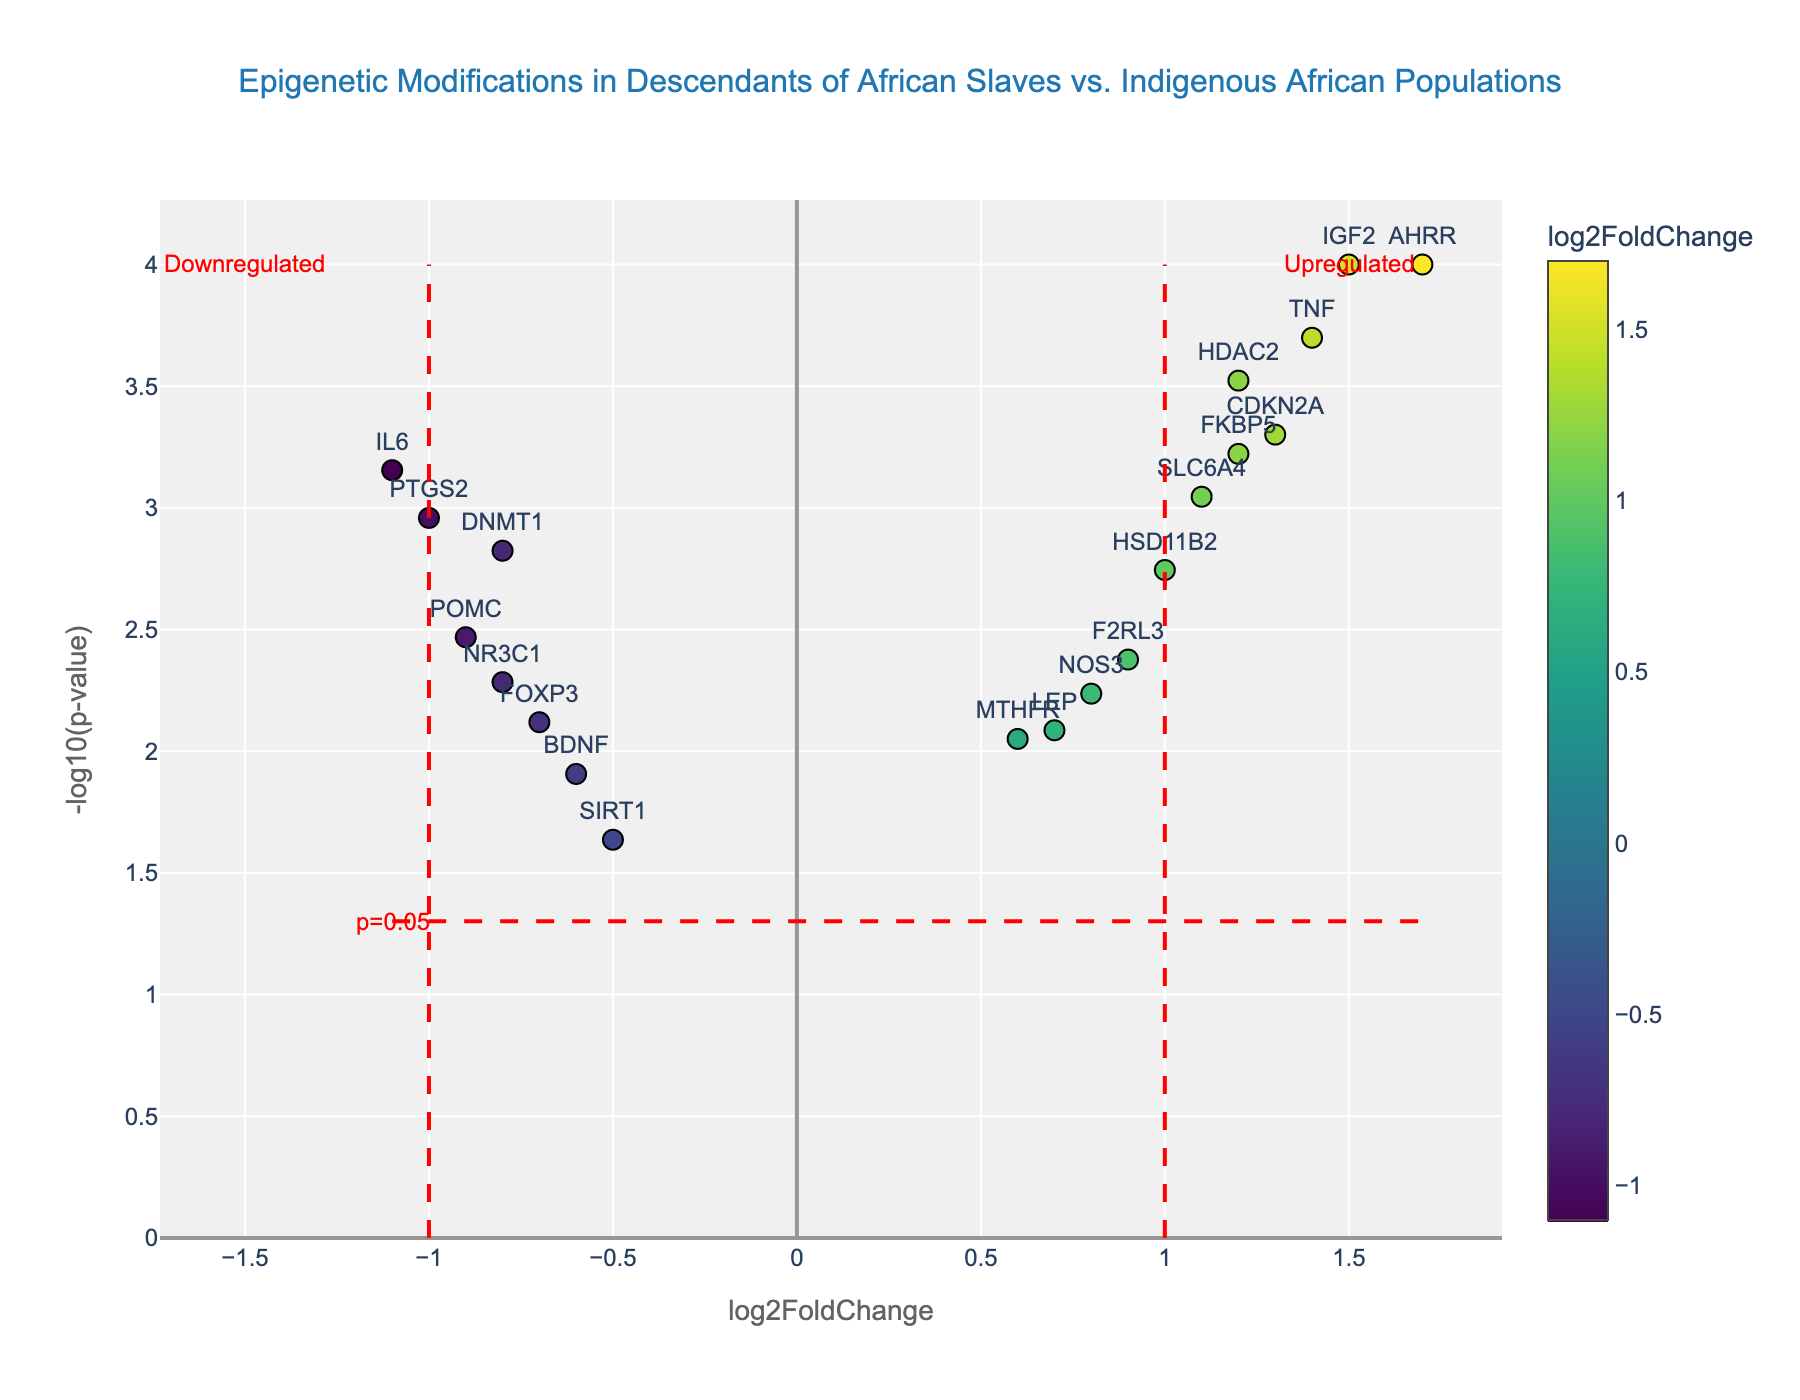What's the title of the figure? The title is usually positioned at the top center of the figure. Here, the title is displayed as 'Epigenetic Modifications in Descendants of African Slaves vs. Indigenous African Populations'.
Answer: Epigenetic Modifications in Descendants of African Slaves vs. Indigenous African Populations How many genes have a negative log2FoldChange? To determine the number of genes with negative log2FoldChange, count the data points to the left of the vertical zero line on the x-axis. Here, genes like DNMT1, SIRT1, IL6, FOXP3, PTGS2, BDNF, POMC, and NR3C1 fall to the left.
Answer: 8 Which gene has the highest -log10(p-value)? To find this, look for the gene positioned the highest on the y-axis. In this figure, AHRR has the highest value.
Answer: AHRR What percentile do genes with p-values less than 0.001 belong to? The threshold of p-value 0.001 corresponds to -log10(p-value) equal to 3 on the y-axis. Count the data points above this threshold to determine the statistical significance. Here, 6 genes (AHRR, HDAC2, TNF, CDKN2A, IGF2, and FKBP5) fall in this category out of a total of 20 genes.
Answer: Top 30% Which two genes have the closest log2FoldChange values? Compare the x-axis positions of all data points. Genes such as DNMT1 (-0.8) and NR3C1 (-0.8) share equivalent values, and similarly, HDAC2 (1.2) and FKBP5 (1.2) do as well.
Answer: DNMT1, NR3C1 and HDAC2, FKBP5 What does the red dashed vertical line at x=1 indicate? This line separates genes with log2FoldChange greater than 1, marking genes significantly upregulated. It serves as a threshold to highlight potential differential expression.
Answer: Upregulated threshold How many genes fall into the significantly upregulated category? Analyze the data points to the right of the red dashed vertical line at x=1. Here, 5 genes (HDAC2, TNF, CDKN2A, IGF2, and FKBP5) meet this criterion.
Answer: 5 Which gene exhibits the largest negative log2FoldChange? The gene positioned furthest to the left on the x-axis represents the largest negative log2FoldChange. In this context, IL6 (-1.1) has the largest.
Answer: IL6 What does the red dashed horizontal line at y=1.3 represent? This line marks the -log10(0.05) threshold, distinguishing p-values less than 0.05 which signify statistical significance.
Answer: Statistical significance threshold Compare the log2FoldChange values of TNF and IL6. Which one is greater? To compare, look at the respective x-axis positions of TNF (1.4) and IL6 (-1.1). TNF's positive log2FoldChange is greater than the negative value of IL6.
Answer: TNF 